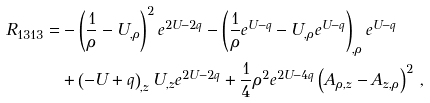Convert formula to latex. <formula><loc_0><loc_0><loc_500><loc_500>R _ { 1 3 1 3 } = & - \left ( \frac { 1 } { \rho } - U _ { , \rho } \right ) ^ { 2 } e ^ { 2 U - 2 q } - \left ( \frac { 1 } { \rho } e ^ { U - q } - U _ { , \rho } e ^ { U - q } \right ) _ { , \rho } e ^ { U - q } \\ & + \left ( - U + q \right ) _ { , z } U _ { , z } e ^ { 2 U - 2 q } + \frac { 1 } { 4 } \rho ^ { 2 } e ^ { 2 U - 4 q } \left ( A _ { \rho , z } - A _ { z , \rho } \right ) ^ { 2 } \, ,</formula> 